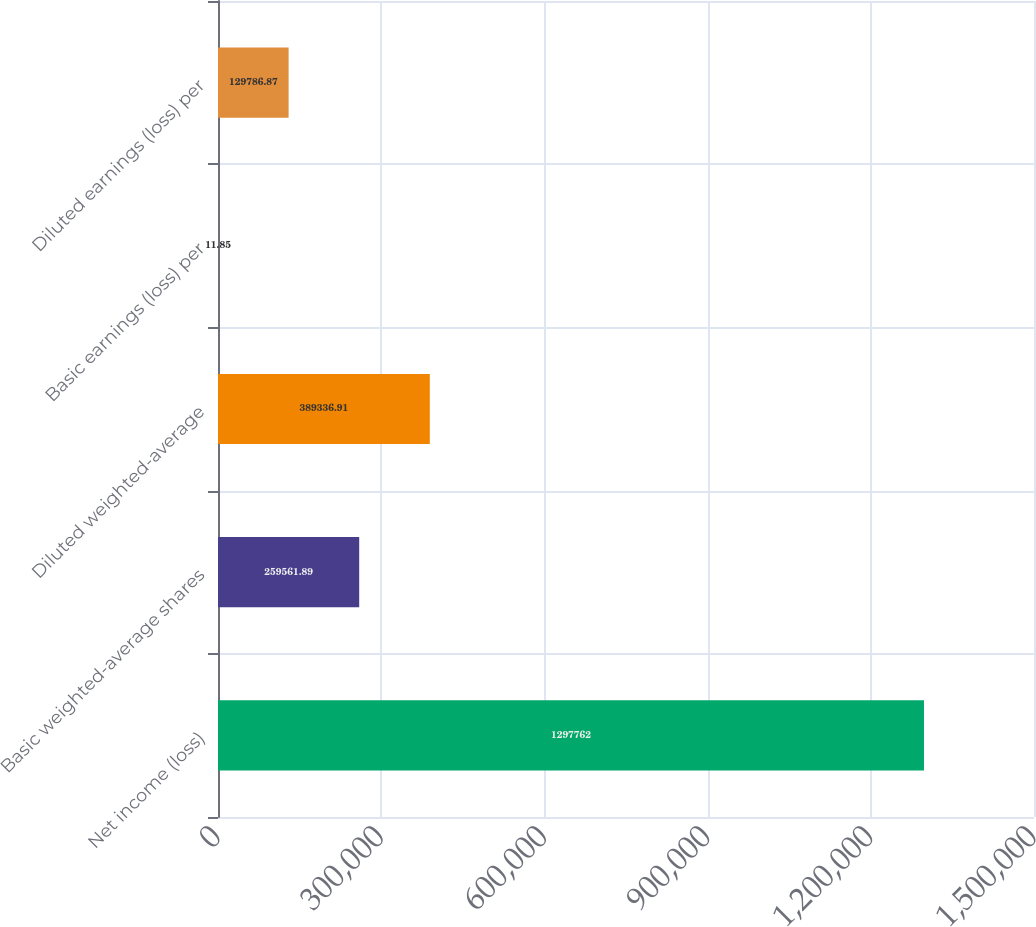<chart> <loc_0><loc_0><loc_500><loc_500><bar_chart><fcel>Net income (loss)<fcel>Basic weighted-average shares<fcel>Diluted weighted-average<fcel>Basic earnings (loss) per<fcel>Diluted earnings (loss) per<nl><fcel>1.29776e+06<fcel>259562<fcel>389337<fcel>11.85<fcel>129787<nl></chart> 